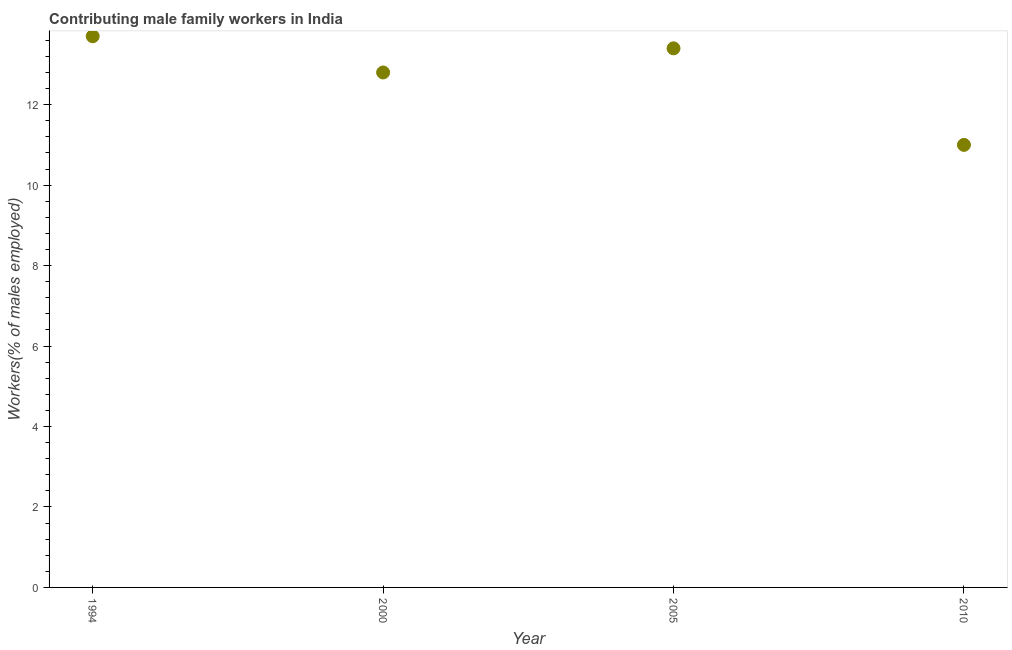What is the contributing male family workers in 2000?
Keep it short and to the point. 12.8. Across all years, what is the maximum contributing male family workers?
Your answer should be very brief. 13.7. Across all years, what is the minimum contributing male family workers?
Ensure brevity in your answer.  11. What is the sum of the contributing male family workers?
Offer a very short reply. 50.9. What is the difference between the contributing male family workers in 1994 and 2010?
Provide a succinct answer. 2.7. What is the average contributing male family workers per year?
Offer a terse response. 12.72. What is the median contributing male family workers?
Your response must be concise. 13.1. In how many years, is the contributing male family workers greater than 6 %?
Provide a short and direct response. 4. What is the ratio of the contributing male family workers in 1994 to that in 2005?
Give a very brief answer. 1.02. Is the contributing male family workers in 1994 less than that in 2005?
Provide a succinct answer. No. Is the difference between the contributing male family workers in 1994 and 2010 greater than the difference between any two years?
Offer a very short reply. Yes. What is the difference between the highest and the second highest contributing male family workers?
Provide a succinct answer. 0.3. What is the difference between the highest and the lowest contributing male family workers?
Give a very brief answer. 2.7. How many dotlines are there?
Give a very brief answer. 1. How many years are there in the graph?
Make the answer very short. 4. What is the title of the graph?
Your response must be concise. Contributing male family workers in India. What is the label or title of the Y-axis?
Offer a terse response. Workers(% of males employed). What is the Workers(% of males employed) in 1994?
Provide a succinct answer. 13.7. What is the Workers(% of males employed) in 2000?
Keep it short and to the point. 12.8. What is the Workers(% of males employed) in 2005?
Make the answer very short. 13.4. What is the difference between the Workers(% of males employed) in 1994 and 2000?
Your answer should be compact. 0.9. What is the difference between the Workers(% of males employed) in 2005 and 2010?
Give a very brief answer. 2.4. What is the ratio of the Workers(% of males employed) in 1994 to that in 2000?
Provide a short and direct response. 1.07. What is the ratio of the Workers(% of males employed) in 1994 to that in 2005?
Keep it short and to the point. 1.02. What is the ratio of the Workers(% of males employed) in 1994 to that in 2010?
Give a very brief answer. 1.25. What is the ratio of the Workers(% of males employed) in 2000 to that in 2005?
Your answer should be compact. 0.95. What is the ratio of the Workers(% of males employed) in 2000 to that in 2010?
Keep it short and to the point. 1.16. What is the ratio of the Workers(% of males employed) in 2005 to that in 2010?
Your answer should be compact. 1.22. 